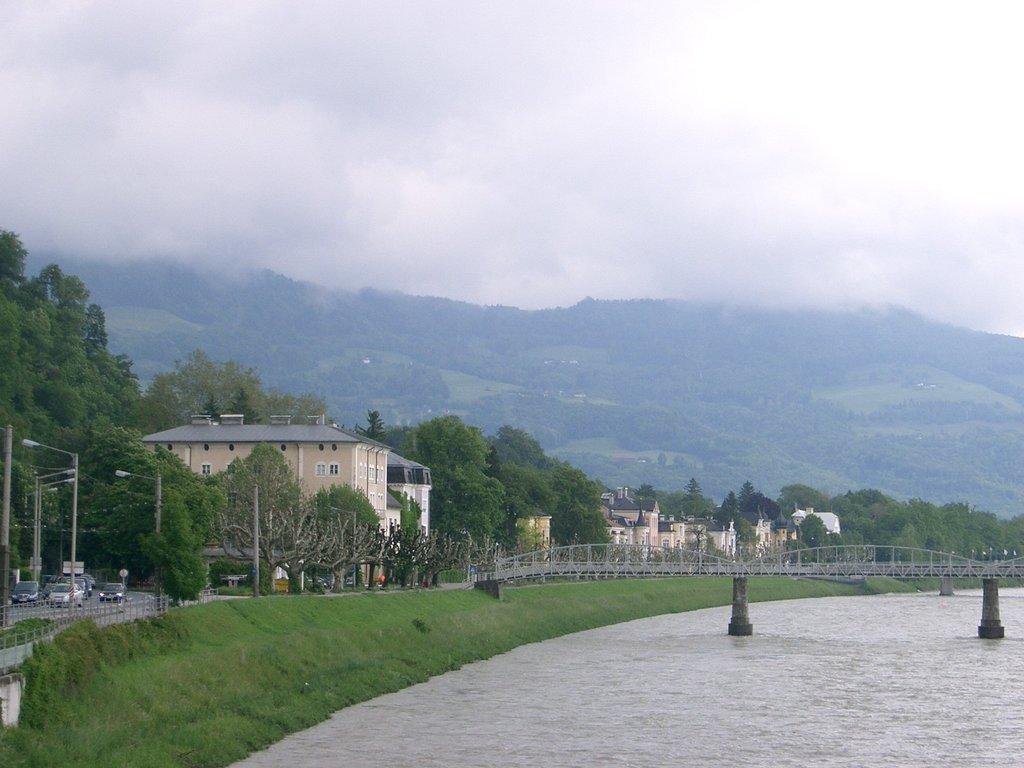Could you give a brief overview of what you see in this image? In this image there are buildings and trees. At the bottom there is water and we can see a bridge. On the left there are vehicles on the road. We can see poles. In the background there are hills and sky. 